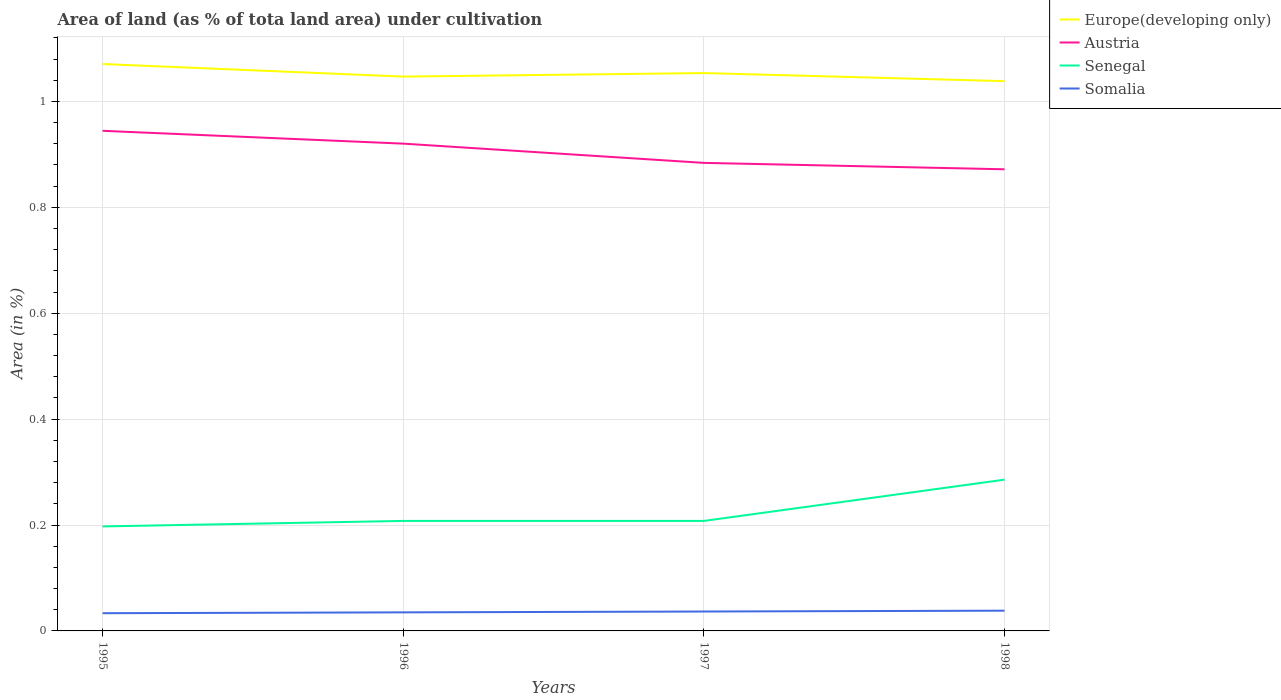How many different coloured lines are there?
Your response must be concise. 4. Does the line corresponding to Somalia intersect with the line corresponding to Senegal?
Provide a succinct answer. No. Is the number of lines equal to the number of legend labels?
Make the answer very short. Yes. Across all years, what is the maximum percentage of land under cultivation in Somalia?
Ensure brevity in your answer.  0.03. What is the total percentage of land under cultivation in Senegal in the graph?
Ensure brevity in your answer.  -0.08. What is the difference between the highest and the second highest percentage of land under cultivation in Senegal?
Provide a succinct answer. 0.09. Is the percentage of land under cultivation in Senegal strictly greater than the percentage of land under cultivation in Somalia over the years?
Keep it short and to the point. No. How many lines are there?
Offer a terse response. 4. Does the graph contain grids?
Make the answer very short. Yes. How many legend labels are there?
Your response must be concise. 4. What is the title of the graph?
Offer a terse response. Area of land (as % of tota land area) under cultivation. What is the label or title of the X-axis?
Offer a terse response. Years. What is the label or title of the Y-axis?
Give a very brief answer. Area (in %). What is the Area (in %) of Europe(developing only) in 1995?
Keep it short and to the point. 1.07. What is the Area (in %) in Austria in 1995?
Provide a succinct answer. 0.94. What is the Area (in %) of Senegal in 1995?
Provide a succinct answer. 0.2. What is the Area (in %) in Somalia in 1995?
Your response must be concise. 0.03. What is the Area (in %) in Europe(developing only) in 1996?
Your answer should be compact. 1.05. What is the Area (in %) of Austria in 1996?
Provide a succinct answer. 0.92. What is the Area (in %) in Senegal in 1996?
Make the answer very short. 0.21. What is the Area (in %) of Somalia in 1996?
Make the answer very short. 0.04. What is the Area (in %) of Europe(developing only) in 1997?
Offer a very short reply. 1.05. What is the Area (in %) of Austria in 1997?
Offer a very short reply. 0.88. What is the Area (in %) of Senegal in 1997?
Provide a succinct answer. 0.21. What is the Area (in %) of Somalia in 1997?
Offer a terse response. 0.04. What is the Area (in %) of Europe(developing only) in 1998?
Provide a succinct answer. 1.04. What is the Area (in %) in Austria in 1998?
Keep it short and to the point. 0.87. What is the Area (in %) of Senegal in 1998?
Provide a succinct answer. 0.29. What is the Area (in %) in Somalia in 1998?
Your answer should be very brief. 0.04. Across all years, what is the maximum Area (in %) of Europe(developing only)?
Your answer should be very brief. 1.07. Across all years, what is the maximum Area (in %) in Austria?
Provide a short and direct response. 0.94. Across all years, what is the maximum Area (in %) in Senegal?
Keep it short and to the point. 0.29. Across all years, what is the maximum Area (in %) in Somalia?
Ensure brevity in your answer.  0.04. Across all years, what is the minimum Area (in %) in Europe(developing only)?
Provide a succinct answer. 1.04. Across all years, what is the minimum Area (in %) in Austria?
Keep it short and to the point. 0.87. Across all years, what is the minimum Area (in %) of Senegal?
Provide a succinct answer. 0.2. Across all years, what is the minimum Area (in %) of Somalia?
Your response must be concise. 0.03. What is the total Area (in %) in Europe(developing only) in the graph?
Offer a very short reply. 4.21. What is the total Area (in %) in Austria in the graph?
Offer a very short reply. 3.62. What is the total Area (in %) of Senegal in the graph?
Make the answer very short. 0.9. What is the total Area (in %) in Somalia in the graph?
Your response must be concise. 0.14. What is the difference between the Area (in %) of Europe(developing only) in 1995 and that in 1996?
Your answer should be compact. 0.02. What is the difference between the Area (in %) in Austria in 1995 and that in 1996?
Your response must be concise. 0.02. What is the difference between the Area (in %) of Senegal in 1995 and that in 1996?
Give a very brief answer. -0.01. What is the difference between the Area (in %) of Somalia in 1995 and that in 1996?
Your answer should be compact. -0. What is the difference between the Area (in %) in Europe(developing only) in 1995 and that in 1997?
Offer a terse response. 0.02. What is the difference between the Area (in %) in Austria in 1995 and that in 1997?
Offer a terse response. 0.06. What is the difference between the Area (in %) in Senegal in 1995 and that in 1997?
Offer a terse response. -0.01. What is the difference between the Area (in %) in Somalia in 1995 and that in 1997?
Offer a terse response. -0. What is the difference between the Area (in %) in Europe(developing only) in 1995 and that in 1998?
Your answer should be compact. 0.03. What is the difference between the Area (in %) in Austria in 1995 and that in 1998?
Keep it short and to the point. 0.07. What is the difference between the Area (in %) of Senegal in 1995 and that in 1998?
Provide a succinct answer. -0.09. What is the difference between the Area (in %) in Somalia in 1995 and that in 1998?
Your response must be concise. -0. What is the difference between the Area (in %) of Europe(developing only) in 1996 and that in 1997?
Your answer should be compact. -0.01. What is the difference between the Area (in %) in Austria in 1996 and that in 1997?
Ensure brevity in your answer.  0.04. What is the difference between the Area (in %) of Senegal in 1996 and that in 1997?
Offer a very short reply. 0. What is the difference between the Area (in %) of Somalia in 1996 and that in 1997?
Keep it short and to the point. -0. What is the difference between the Area (in %) in Europe(developing only) in 1996 and that in 1998?
Your answer should be compact. 0.01. What is the difference between the Area (in %) of Austria in 1996 and that in 1998?
Your answer should be very brief. 0.05. What is the difference between the Area (in %) in Senegal in 1996 and that in 1998?
Your response must be concise. -0.08. What is the difference between the Area (in %) in Somalia in 1996 and that in 1998?
Your response must be concise. -0. What is the difference between the Area (in %) of Europe(developing only) in 1997 and that in 1998?
Make the answer very short. 0.02. What is the difference between the Area (in %) in Austria in 1997 and that in 1998?
Your response must be concise. 0.01. What is the difference between the Area (in %) in Senegal in 1997 and that in 1998?
Your answer should be very brief. -0.08. What is the difference between the Area (in %) in Somalia in 1997 and that in 1998?
Your answer should be very brief. -0. What is the difference between the Area (in %) in Europe(developing only) in 1995 and the Area (in %) in Austria in 1996?
Your response must be concise. 0.15. What is the difference between the Area (in %) in Europe(developing only) in 1995 and the Area (in %) in Senegal in 1996?
Ensure brevity in your answer.  0.86. What is the difference between the Area (in %) of Europe(developing only) in 1995 and the Area (in %) of Somalia in 1996?
Make the answer very short. 1.04. What is the difference between the Area (in %) of Austria in 1995 and the Area (in %) of Senegal in 1996?
Provide a short and direct response. 0.74. What is the difference between the Area (in %) of Austria in 1995 and the Area (in %) of Somalia in 1996?
Make the answer very short. 0.91. What is the difference between the Area (in %) of Senegal in 1995 and the Area (in %) of Somalia in 1996?
Ensure brevity in your answer.  0.16. What is the difference between the Area (in %) in Europe(developing only) in 1995 and the Area (in %) in Austria in 1997?
Give a very brief answer. 0.19. What is the difference between the Area (in %) of Europe(developing only) in 1995 and the Area (in %) of Senegal in 1997?
Your response must be concise. 0.86. What is the difference between the Area (in %) in Europe(developing only) in 1995 and the Area (in %) in Somalia in 1997?
Offer a very short reply. 1.03. What is the difference between the Area (in %) of Austria in 1995 and the Area (in %) of Senegal in 1997?
Your response must be concise. 0.74. What is the difference between the Area (in %) of Austria in 1995 and the Area (in %) of Somalia in 1997?
Ensure brevity in your answer.  0.91. What is the difference between the Area (in %) of Senegal in 1995 and the Area (in %) of Somalia in 1997?
Make the answer very short. 0.16. What is the difference between the Area (in %) of Europe(developing only) in 1995 and the Area (in %) of Austria in 1998?
Offer a terse response. 0.2. What is the difference between the Area (in %) in Europe(developing only) in 1995 and the Area (in %) in Senegal in 1998?
Your answer should be compact. 0.79. What is the difference between the Area (in %) of Europe(developing only) in 1995 and the Area (in %) of Somalia in 1998?
Your answer should be very brief. 1.03. What is the difference between the Area (in %) in Austria in 1995 and the Area (in %) in Senegal in 1998?
Your response must be concise. 0.66. What is the difference between the Area (in %) of Austria in 1995 and the Area (in %) of Somalia in 1998?
Provide a short and direct response. 0.91. What is the difference between the Area (in %) in Senegal in 1995 and the Area (in %) in Somalia in 1998?
Provide a succinct answer. 0.16. What is the difference between the Area (in %) in Europe(developing only) in 1996 and the Area (in %) in Austria in 1997?
Provide a short and direct response. 0.16. What is the difference between the Area (in %) of Europe(developing only) in 1996 and the Area (in %) of Senegal in 1997?
Keep it short and to the point. 0.84. What is the difference between the Area (in %) of Europe(developing only) in 1996 and the Area (in %) of Somalia in 1997?
Offer a very short reply. 1.01. What is the difference between the Area (in %) in Austria in 1996 and the Area (in %) in Senegal in 1997?
Your response must be concise. 0.71. What is the difference between the Area (in %) of Austria in 1996 and the Area (in %) of Somalia in 1997?
Give a very brief answer. 0.88. What is the difference between the Area (in %) of Senegal in 1996 and the Area (in %) of Somalia in 1997?
Ensure brevity in your answer.  0.17. What is the difference between the Area (in %) of Europe(developing only) in 1996 and the Area (in %) of Austria in 1998?
Offer a very short reply. 0.17. What is the difference between the Area (in %) of Europe(developing only) in 1996 and the Area (in %) of Senegal in 1998?
Ensure brevity in your answer.  0.76. What is the difference between the Area (in %) in Europe(developing only) in 1996 and the Area (in %) in Somalia in 1998?
Keep it short and to the point. 1.01. What is the difference between the Area (in %) of Austria in 1996 and the Area (in %) of Senegal in 1998?
Give a very brief answer. 0.63. What is the difference between the Area (in %) in Austria in 1996 and the Area (in %) in Somalia in 1998?
Your answer should be compact. 0.88. What is the difference between the Area (in %) in Senegal in 1996 and the Area (in %) in Somalia in 1998?
Keep it short and to the point. 0.17. What is the difference between the Area (in %) in Europe(developing only) in 1997 and the Area (in %) in Austria in 1998?
Provide a succinct answer. 0.18. What is the difference between the Area (in %) in Europe(developing only) in 1997 and the Area (in %) in Senegal in 1998?
Make the answer very short. 0.77. What is the difference between the Area (in %) of Europe(developing only) in 1997 and the Area (in %) of Somalia in 1998?
Provide a short and direct response. 1.02. What is the difference between the Area (in %) in Austria in 1997 and the Area (in %) in Senegal in 1998?
Give a very brief answer. 0.6. What is the difference between the Area (in %) of Austria in 1997 and the Area (in %) of Somalia in 1998?
Your response must be concise. 0.85. What is the difference between the Area (in %) of Senegal in 1997 and the Area (in %) of Somalia in 1998?
Ensure brevity in your answer.  0.17. What is the average Area (in %) in Europe(developing only) per year?
Ensure brevity in your answer.  1.05. What is the average Area (in %) of Austria per year?
Provide a succinct answer. 0.91. What is the average Area (in %) of Senegal per year?
Make the answer very short. 0.22. What is the average Area (in %) of Somalia per year?
Give a very brief answer. 0.04. In the year 1995, what is the difference between the Area (in %) in Europe(developing only) and Area (in %) in Austria?
Keep it short and to the point. 0.13. In the year 1995, what is the difference between the Area (in %) of Europe(developing only) and Area (in %) of Senegal?
Keep it short and to the point. 0.87. In the year 1995, what is the difference between the Area (in %) of Europe(developing only) and Area (in %) of Somalia?
Offer a terse response. 1.04. In the year 1995, what is the difference between the Area (in %) in Austria and Area (in %) in Senegal?
Make the answer very short. 0.75. In the year 1995, what is the difference between the Area (in %) in Austria and Area (in %) in Somalia?
Your answer should be compact. 0.91. In the year 1995, what is the difference between the Area (in %) of Senegal and Area (in %) of Somalia?
Provide a short and direct response. 0.16. In the year 1996, what is the difference between the Area (in %) in Europe(developing only) and Area (in %) in Austria?
Offer a terse response. 0.13. In the year 1996, what is the difference between the Area (in %) of Europe(developing only) and Area (in %) of Senegal?
Offer a terse response. 0.84. In the year 1996, what is the difference between the Area (in %) of Europe(developing only) and Area (in %) of Somalia?
Provide a succinct answer. 1.01. In the year 1996, what is the difference between the Area (in %) in Austria and Area (in %) in Senegal?
Provide a short and direct response. 0.71. In the year 1996, what is the difference between the Area (in %) in Austria and Area (in %) in Somalia?
Offer a very short reply. 0.89. In the year 1996, what is the difference between the Area (in %) of Senegal and Area (in %) of Somalia?
Offer a very short reply. 0.17. In the year 1997, what is the difference between the Area (in %) of Europe(developing only) and Area (in %) of Austria?
Provide a succinct answer. 0.17. In the year 1997, what is the difference between the Area (in %) of Europe(developing only) and Area (in %) of Senegal?
Offer a terse response. 0.85. In the year 1997, what is the difference between the Area (in %) of Europe(developing only) and Area (in %) of Somalia?
Make the answer very short. 1.02. In the year 1997, what is the difference between the Area (in %) in Austria and Area (in %) in Senegal?
Keep it short and to the point. 0.68. In the year 1997, what is the difference between the Area (in %) in Austria and Area (in %) in Somalia?
Provide a succinct answer. 0.85. In the year 1997, what is the difference between the Area (in %) of Senegal and Area (in %) of Somalia?
Make the answer very short. 0.17. In the year 1998, what is the difference between the Area (in %) of Europe(developing only) and Area (in %) of Austria?
Your response must be concise. 0.17. In the year 1998, what is the difference between the Area (in %) of Europe(developing only) and Area (in %) of Senegal?
Provide a succinct answer. 0.75. In the year 1998, what is the difference between the Area (in %) in Europe(developing only) and Area (in %) in Somalia?
Provide a short and direct response. 1. In the year 1998, what is the difference between the Area (in %) in Austria and Area (in %) in Senegal?
Ensure brevity in your answer.  0.59. In the year 1998, what is the difference between the Area (in %) of Austria and Area (in %) of Somalia?
Ensure brevity in your answer.  0.83. In the year 1998, what is the difference between the Area (in %) of Senegal and Area (in %) of Somalia?
Offer a very short reply. 0.25. What is the ratio of the Area (in %) of Europe(developing only) in 1995 to that in 1996?
Give a very brief answer. 1.02. What is the ratio of the Area (in %) of Austria in 1995 to that in 1996?
Provide a short and direct response. 1.03. What is the ratio of the Area (in %) of Senegal in 1995 to that in 1996?
Your answer should be very brief. 0.95. What is the ratio of the Area (in %) in Somalia in 1995 to that in 1996?
Keep it short and to the point. 0.95. What is the ratio of the Area (in %) of Europe(developing only) in 1995 to that in 1997?
Your answer should be very brief. 1.02. What is the ratio of the Area (in %) in Austria in 1995 to that in 1997?
Provide a short and direct response. 1.07. What is the ratio of the Area (in %) in Europe(developing only) in 1995 to that in 1998?
Provide a short and direct response. 1.03. What is the ratio of the Area (in %) in Austria in 1995 to that in 1998?
Offer a terse response. 1.08. What is the ratio of the Area (in %) in Senegal in 1995 to that in 1998?
Your answer should be very brief. 0.69. What is the ratio of the Area (in %) of Europe(developing only) in 1996 to that in 1997?
Your answer should be very brief. 0.99. What is the ratio of the Area (in %) of Austria in 1996 to that in 1997?
Your response must be concise. 1.04. What is the ratio of the Area (in %) of Somalia in 1996 to that in 1997?
Your answer should be compact. 0.96. What is the ratio of the Area (in %) in Europe(developing only) in 1996 to that in 1998?
Offer a very short reply. 1.01. What is the ratio of the Area (in %) of Austria in 1996 to that in 1998?
Give a very brief answer. 1.06. What is the ratio of the Area (in %) in Senegal in 1996 to that in 1998?
Ensure brevity in your answer.  0.73. What is the ratio of the Area (in %) in Europe(developing only) in 1997 to that in 1998?
Provide a succinct answer. 1.01. What is the ratio of the Area (in %) in Austria in 1997 to that in 1998?
Keep it short and to the point. 1.01. What is the ratio of the Area (in %) in Senegal in 1997 to that in 1998?
Offer a very short reply. 0.73. What is the difference between the highest and the second highest Area (in %) in Europe(developing only)?
Provide a succinct answer. 0.02. What is the difference between the highest and the second highest Area (in %) in Austria?
Provide a short and direct response. 0.02. What is the difference between the highest and the second highest Area (in %) of Senegal?
Give a very brief answer. 0.08. What is the difference between the highest and the second highest Area (in %) in Somalia?
Offer a terse response. 0. What is the difference between the highest and the lowest Area (in %) in Europe(developing only)?
Offer a terse response. 0.03. What is the difference between the highest and the lowest Area (in %) of Austria?
Give a very brief answer. 0.07. What is the difference between the highest and the lowest Area (in %) in Senegal?
Your response must be concise. 0.09. What is the difference between the highest and the lowest Area (in %) of Somalia?
Provide a succinct answer. 0. 